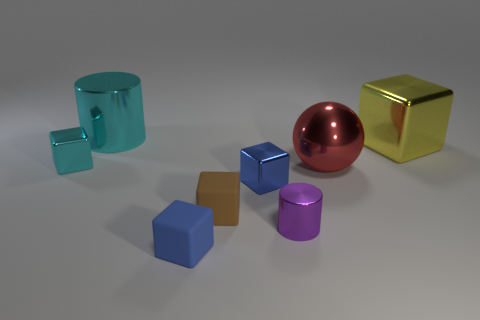Add 1 large shiny balls. How many objects exist? 9 Subtract all brown blocks. How many blocks are left? 4 Subtract all blue cylinders. How many blue cubes are left? 2 Subtract all purple cylinders. How many cylinders are left? 1 Subtract 1 cylinders. How many cylinders are left? 1 Add 5 cubes. How many cubes are left? 10 Add 6 big brown rubber cubes. How many big brown rubber cubes exist? 6 Subtract 0 blue cylinders. How many objects are left? 8 Subtract all blocks. How many objects are left? 3 Subtract all yellow spheres. Subtract all red cubes. How many spheres are left? 1 